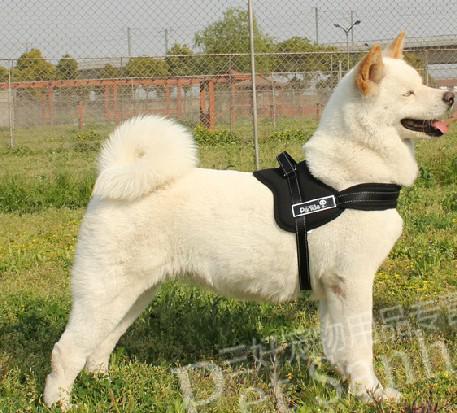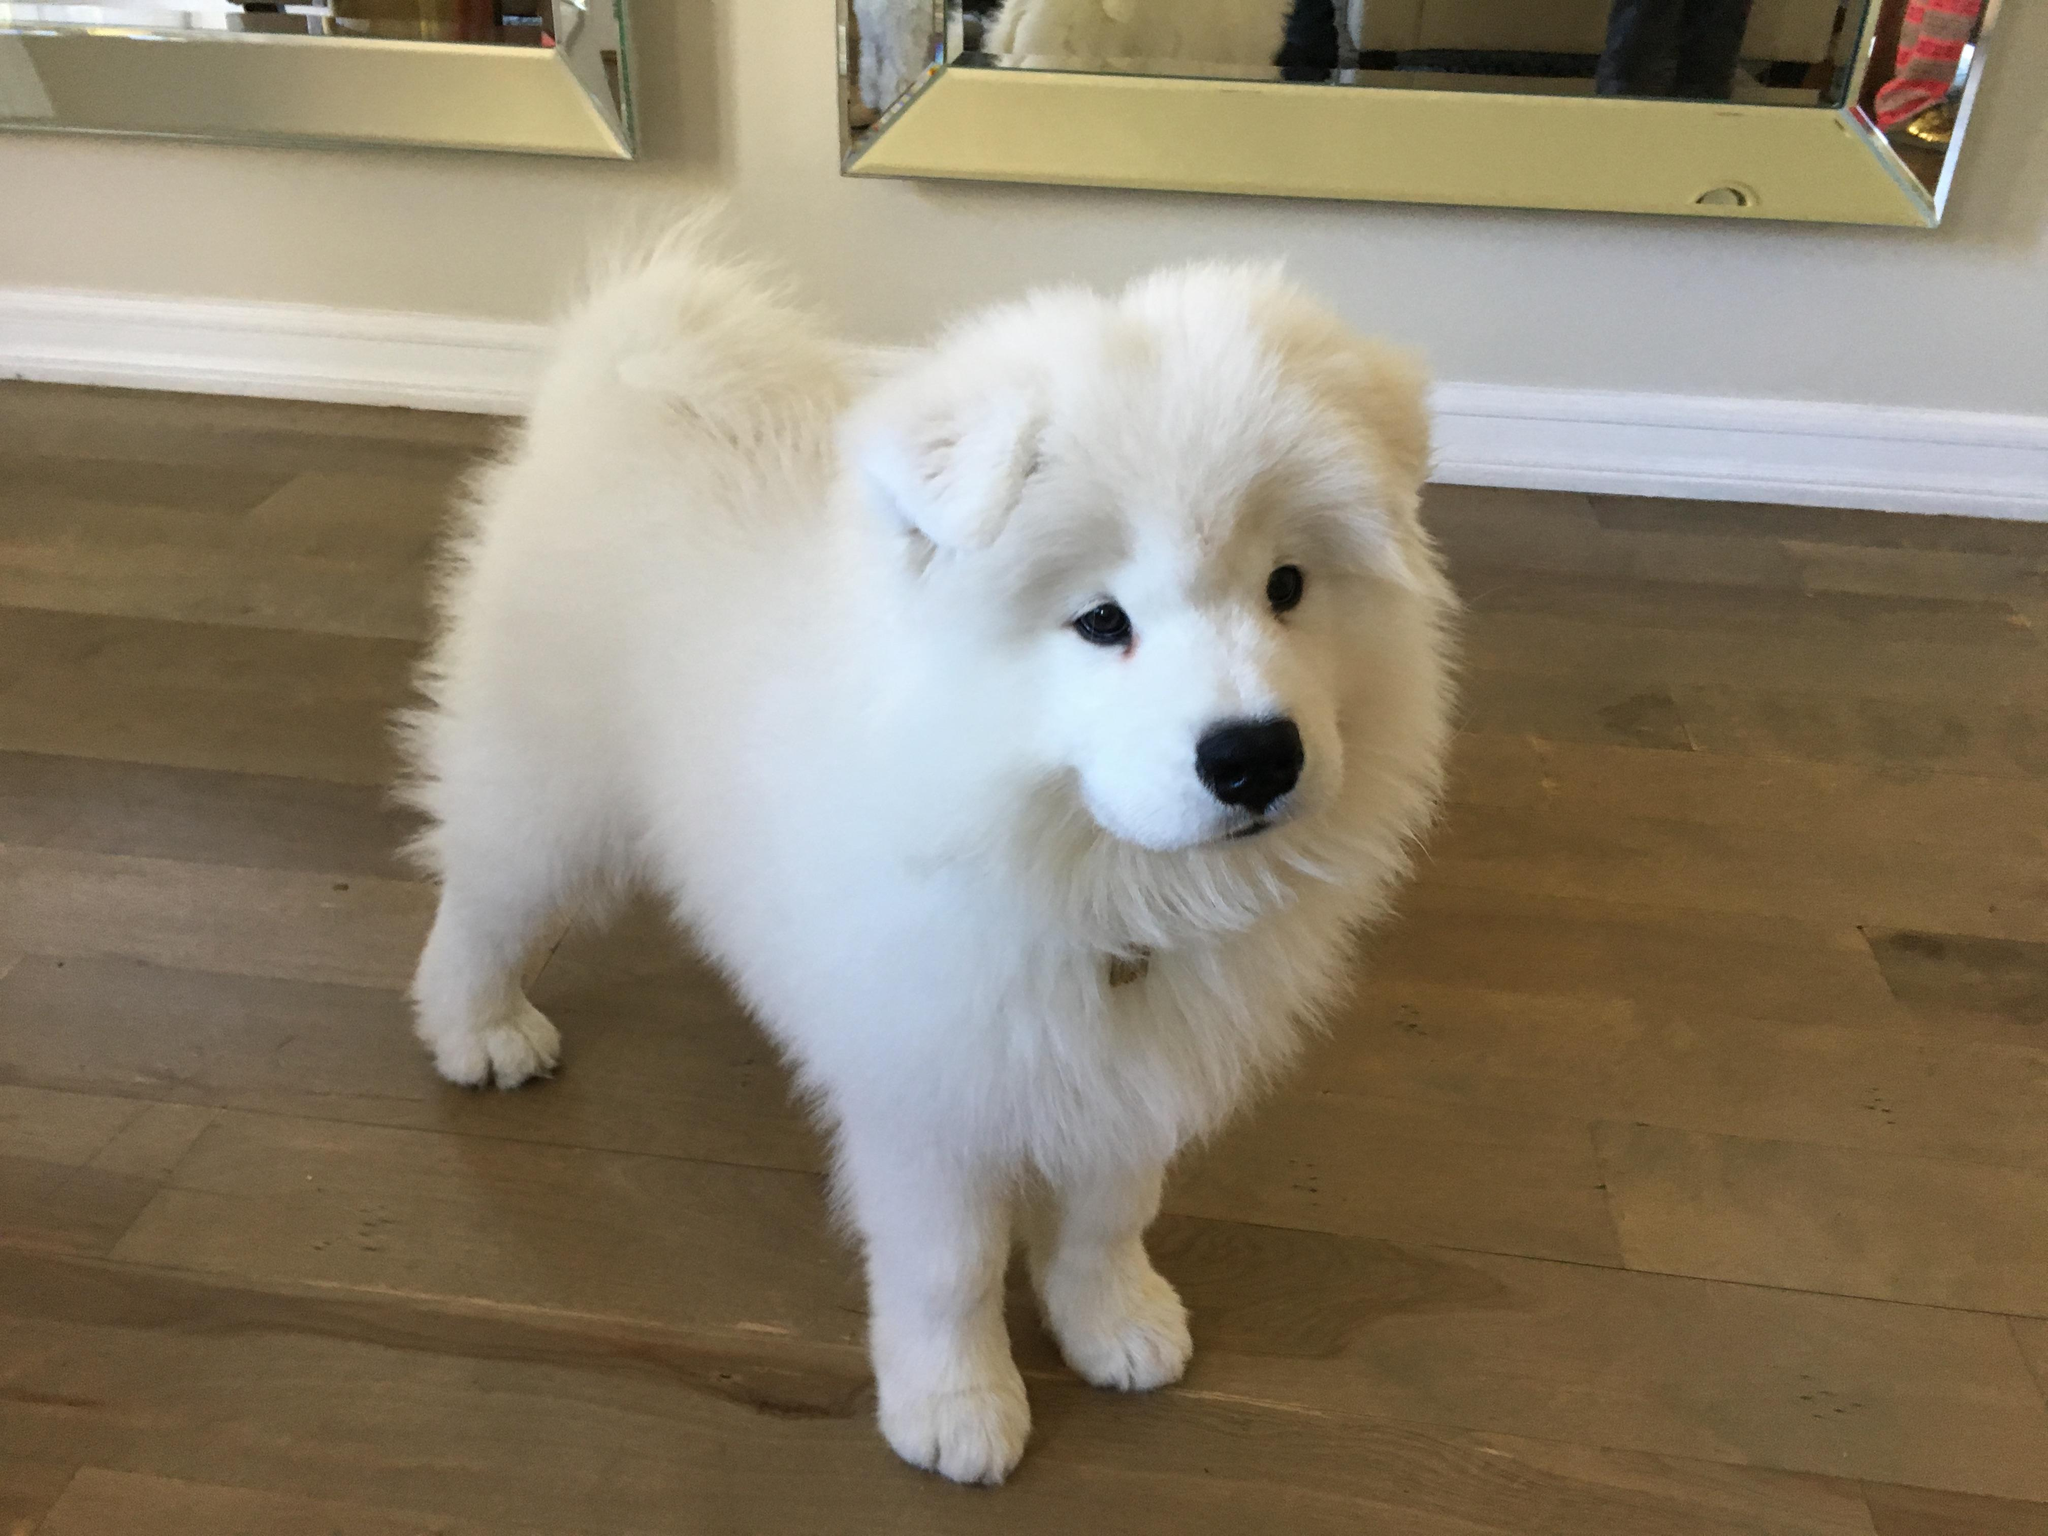The first image is the image on the left, the second image is the image on the right. Analyze the images presented: Is the assertion "Each of two dogs at an outdoor grassy location has its mouth open with tongue showing and is wearing a leash." valid? Answer yes or no. No. The first image is the image on the left, the second image is the image on the right. Considering the images on both sides, is "One image shows a dog in a harness standing with head and body in profile, without a leash visible, and the other image shows a dog without a leash or harness." valid? Answer yes or no. Yes. 